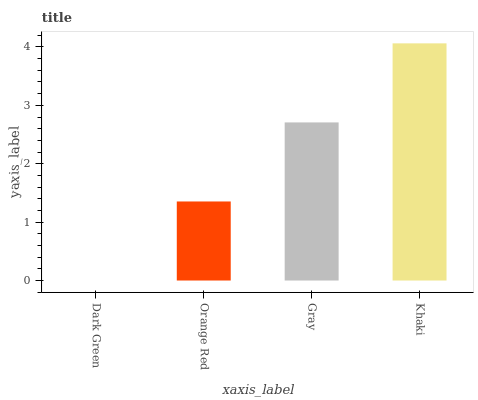Is Dark Green the minimum?
Answer yes or no. Yes. Is Khaki the maximum?
Answer yes or no. Yes. Is Orange Red the minimum?
Answer yes or no. No. Is Orange Red the maximum?
Answer yes or no. No. Is Orange Red greater than Dark Green?
Answer yes or no. Yes. Is Dark Green less than Orange Red?
Answer yes or no. Yes. Is Dark Green greater than Orange Red?
Answer yes or no. No. Is Orange Red less than Dark Green?
Answer yes or no. No. Is Gray the high median?
Answer yes or no. Yes. Is Orange Red the low median?
Answer yes or no. Yes. Is Dark Green the high median?
Answer yes or no. No. Is Khaki the low median?
Answer yes or no. No. 